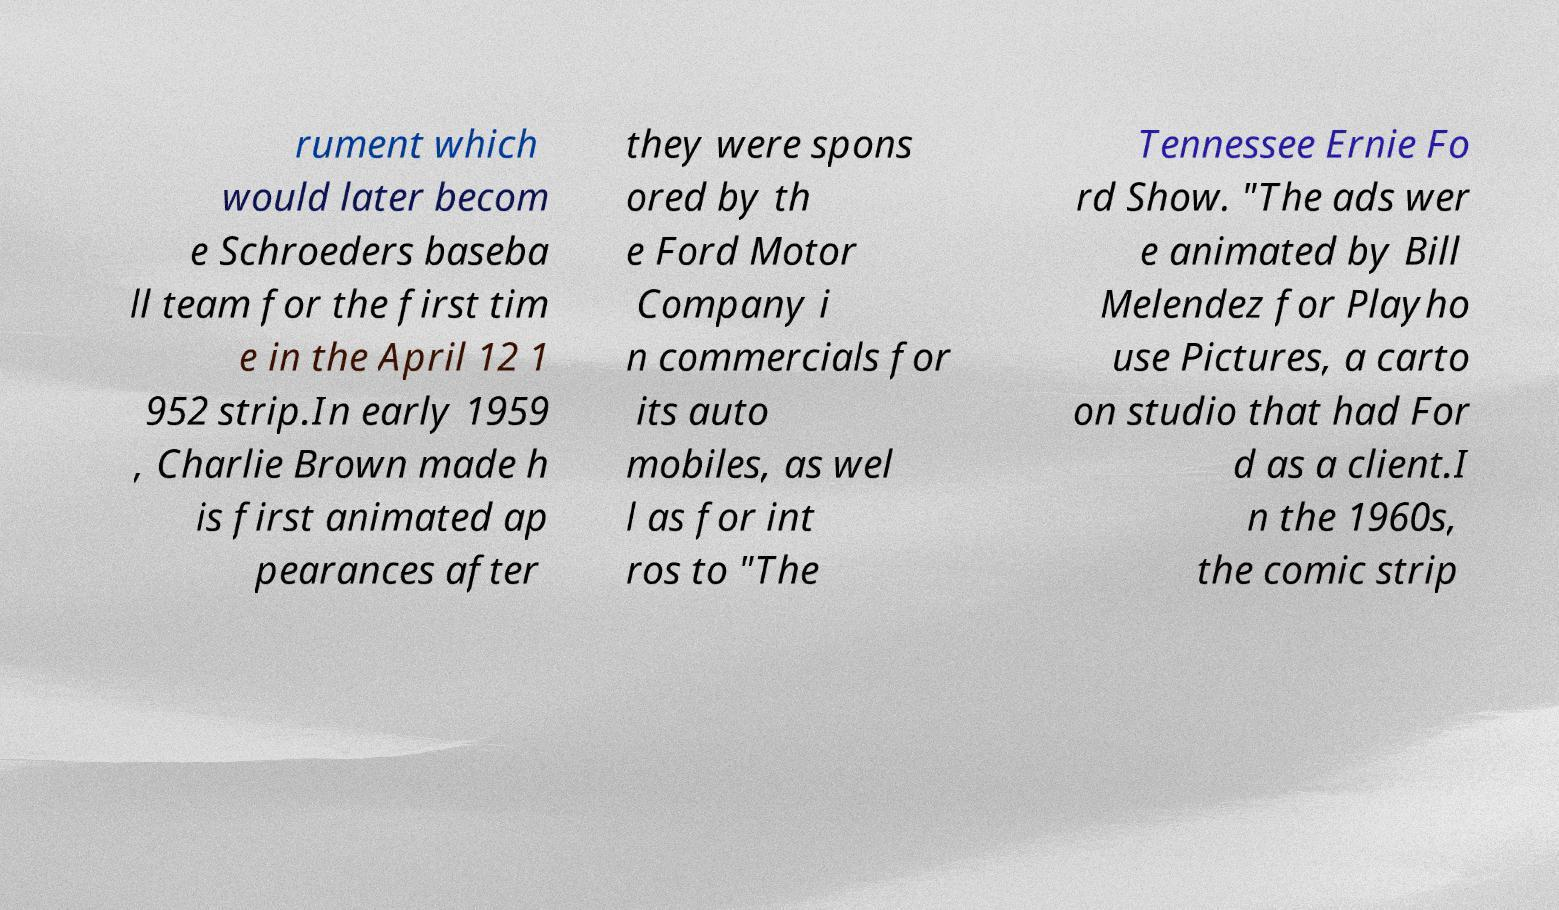I need the written content from this picture converted into text. Can you do that? rument which would later becom e Schroeders baseba ll team for the first tim e in the April 12 1 952 strip.In early 1959 , Charlie Brown made h is first animated ap pearances after they were spons ored by th e Ford Motor Company i n commercials for its auto mobiles, as wel l as for int ros to "The Tennessee Ernie Fo rd Show. "The ads wer e animated by Bill Melendez for Playho use Pictures, a carto on studio that had For d as a client.I n the 1960s, the comic strip 